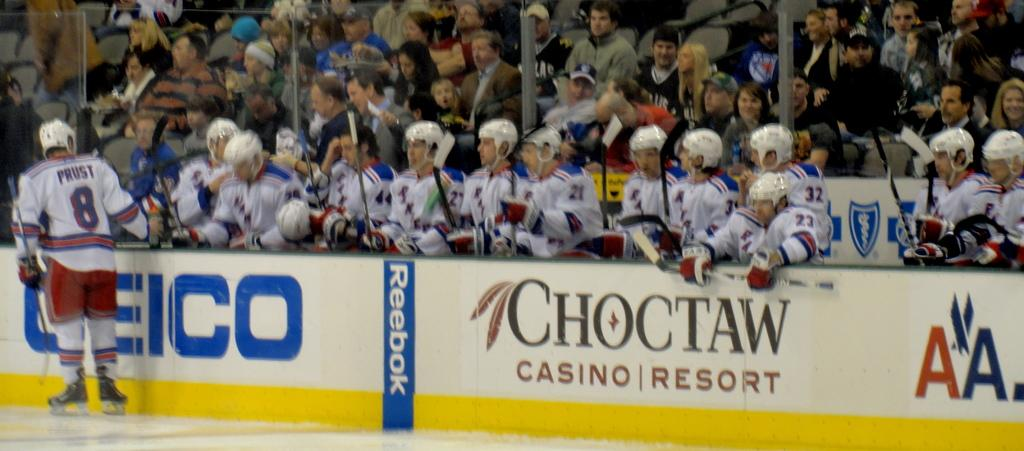<image>
Provide a brief description of the given image. a hockey team with a choctaw ad in front of them 